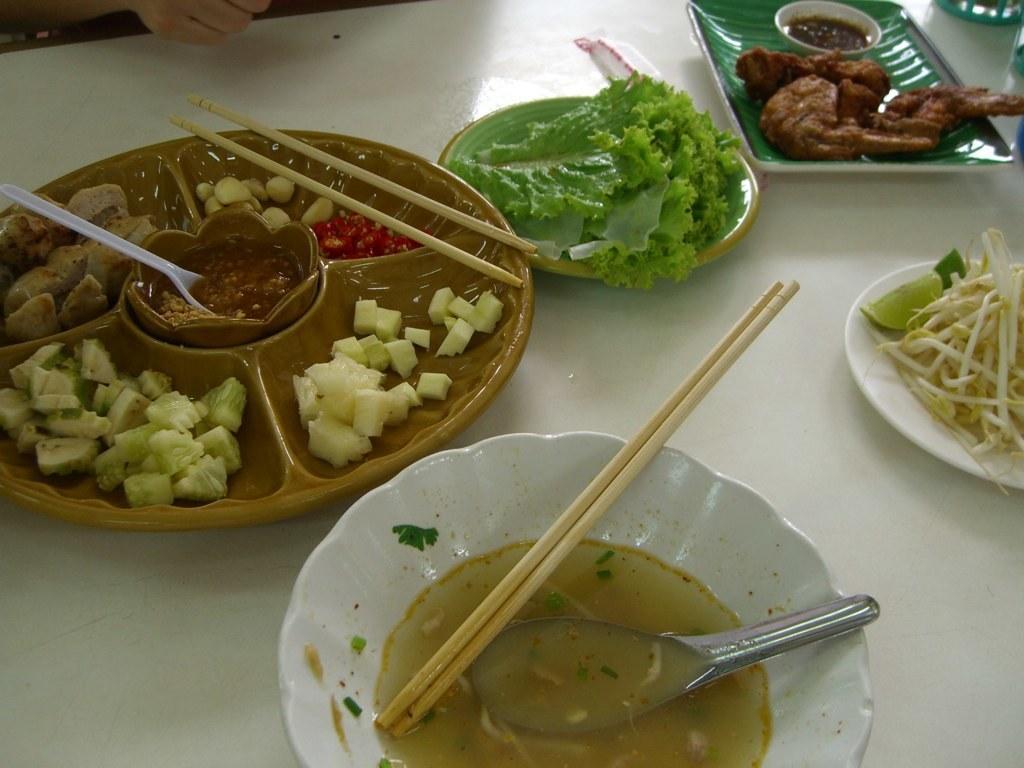Could you give a brief overview of what you see in this image? In this picture we can see plates, chopsticks, spoons, a small bowl some food items on the plates and the plates are on a white object. 